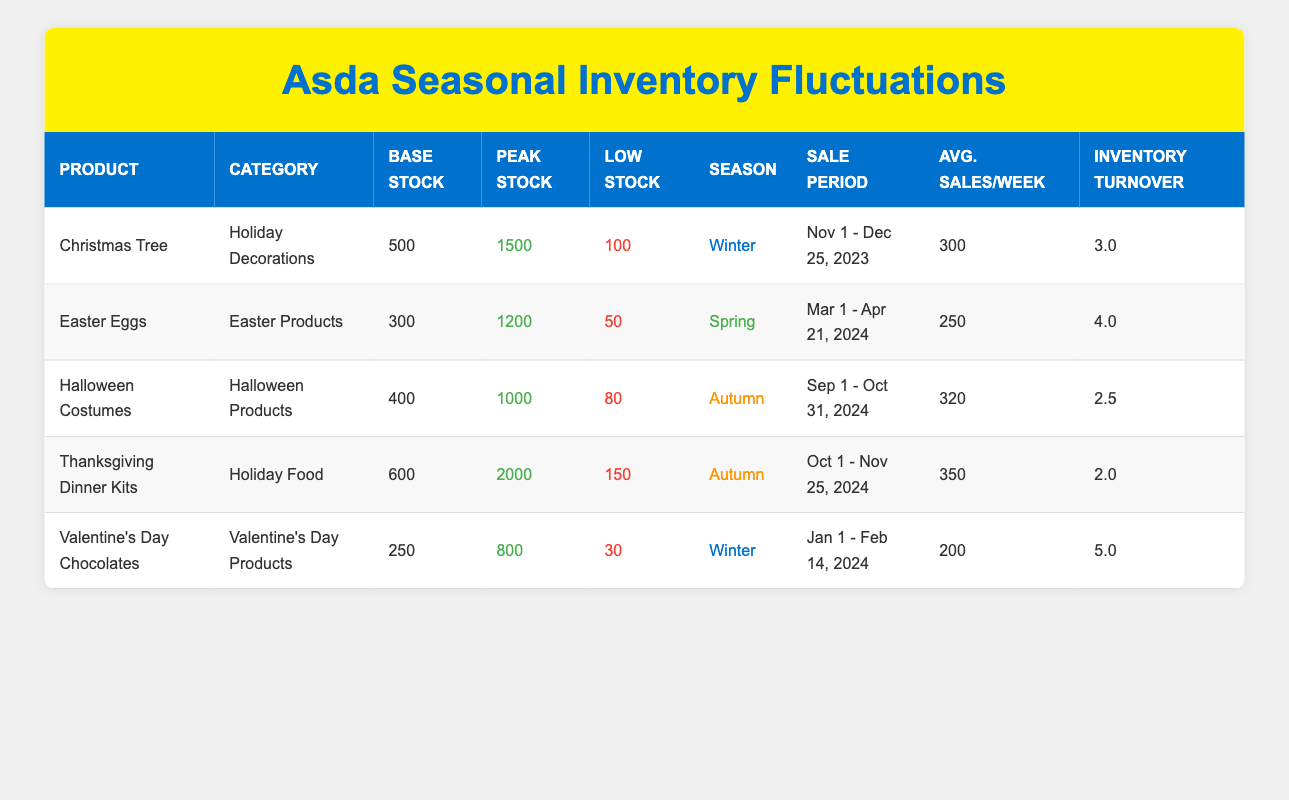What is the peak stock for the Valentine's Day Chocolates? According to the table, the peak stock for Valentine's Day Chocolates is listed directly in the "Peak Stock" column.
Answer: 800 What are the average sales per week for Easter Eggs? The average sales per week for Easter Eggs can be found in the "Avg. Sales/Week" column specific to that product.
Answer: 250 Which product has the highest inventory turnover? By assessing the "Inventory Turnover" column, we compare the turnover rates and determine which product has the highest value. Valentine's Day Chocolates has the highest inventory turnover at 5.0.
Answer: 5.0 How many weeks does the Christmas Tree sale last? The sale for Christmas Trees starts on November 1, 2023, and ends on December 25, 2023. To find the duration, we calculate the number of days between the start and end date and then convert it into weeks. The sale lasts 8 weeks total.
Answer: 8 weeks Is the low stock for Halloween Costumes less than the base stock? By comparing the values in the "Low Stock" and "Base Stock" columns for Halloween Costumes, we find that low stock is 80 and the base stock is 400. Since 80 is less than 400, the statement is true.
Answer: Yes What is the difference between the peak stock and low stock for Thanksgiving Dinner Kits? To find the difference, we subtract the "Low Stock" value from the "Peak Stock" value for Thanksgiving Dinner Kits. That is 2000 (peak stock) - 150 (low stock) = 1850.
Answer: 1850 Which holiday product has the lowest low stock? Evaluating the "Low Stock" values across all products, we identify that Easter Eggs have the lowest low stock value of 50.
Answer: Easter Eggs In which season do Thanksgiving Dinner Kits have their sales? Looking at the "Season" column for Thanksgiving Dinner Kits, it is clear they are categorized under Autumn.
Answer: Autumn What is the total base stock of all winter products? To get the total base stock of winter products, we identify the products under the Winter season (Christmas Tree and Valentine's Day Chocolates) and sum their base stocks: 500 (Christmas Tree) + 250 (Valentine's Day Chocolates) = 750.
Answer: 750 